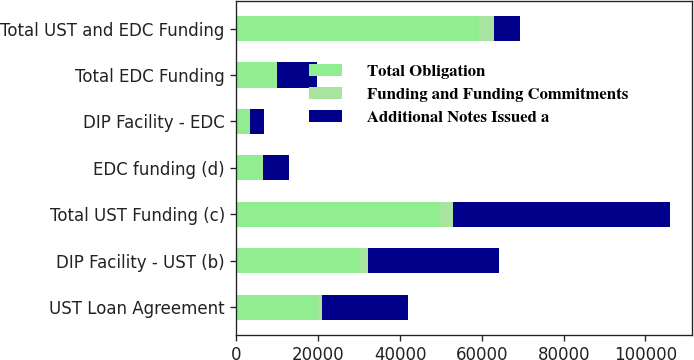<chart> <loc_0><loc_0><loc_500><loc_500><stacked_bar_chart><ecel><fcel>UST Loan Agreement<fcel>DIP Facility - UST (b)<fcel>Total UST Funding (c)<fcel>EDC funding (d)<fcel>DIP Facility - EDC<fcel>Total EDC Funding<fcel>Total UST and EDC Funding<nl><fcel>Total Obligation<fcel>19761<fcel>30100<fcel>49861<fcel>6294<fcel>3200<fcel>9494<fcel>59355<nl><fcel>Funding and Funding Commitments<fcel>1172<fcel>2008<fcel>3180<fcel>161<fcel>213<fcel>374<fcel>3554<nl><fcel>Additional Notes Issued a<fcel>20933<fcel>32108<fcel>53041<fcel>6455<fcel>3413<fcel>9868<fcel>6374.5<nl></chart> 